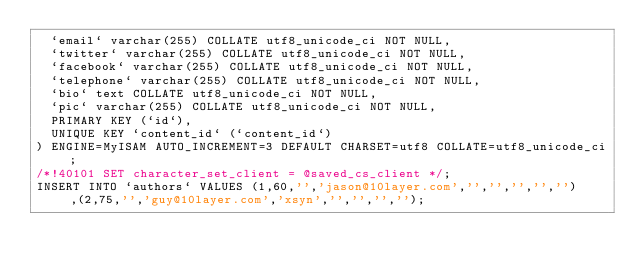<code> <loc_0><loc_0><loc_500><loc_500><_SQL_>  `email` varchar(255) COLLATE utf8_unicode_ci NOT NULL,
  `twitter` varchar(255) COLLATE utf8_unicode_ci NOT NULL,
  `facebook` varchar(255) COLLATE utf8_unicode_ci NOT NULL,
  `telephone` varchar(255) COLLATE utf8_unicode_ci NOT NULL,
  `bio` text COLLATE utf8_unicode_ci NOT NULL,
  `pic` varchar(255) COLLATE utf8_unicode_ci NOT NULL,
  PRIMARY KEY (`id`),
  UNIQUE KEY `content_id` (`content_id`)
) ENGINE=MyISAM AUTO_INCREMENT=3 DEFAULT CHARSET=utf8 COLLATE=utf8_unicode_ci;
/*!40101 SET character_set_client = @saved_cs_client */;
INSERT INTO `authors` VALUES (1,60,'','jason@10layer.com','','','','',''),(2,75,'','guy@10layer.com','xsyn','','','','');
</code> 